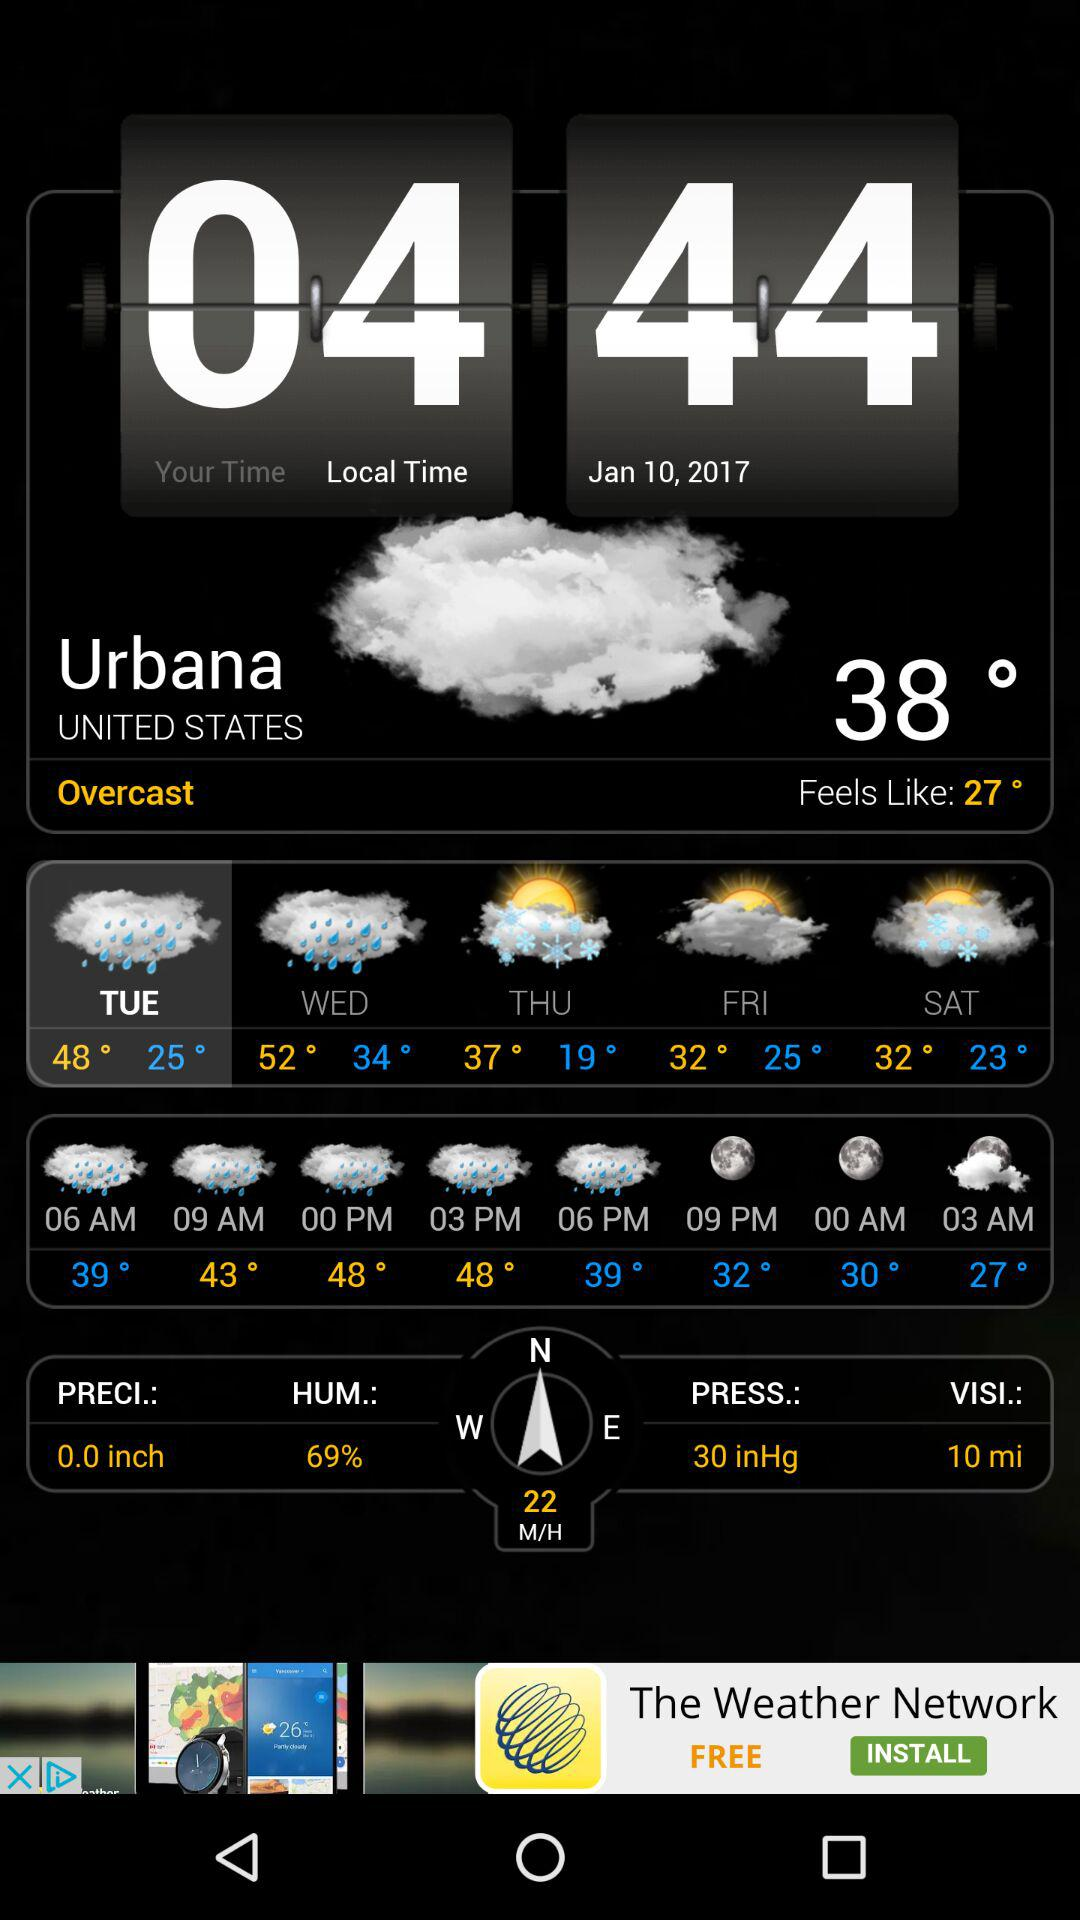What is the humidity for today?
Answer the question using a single word or phrase. 69% 